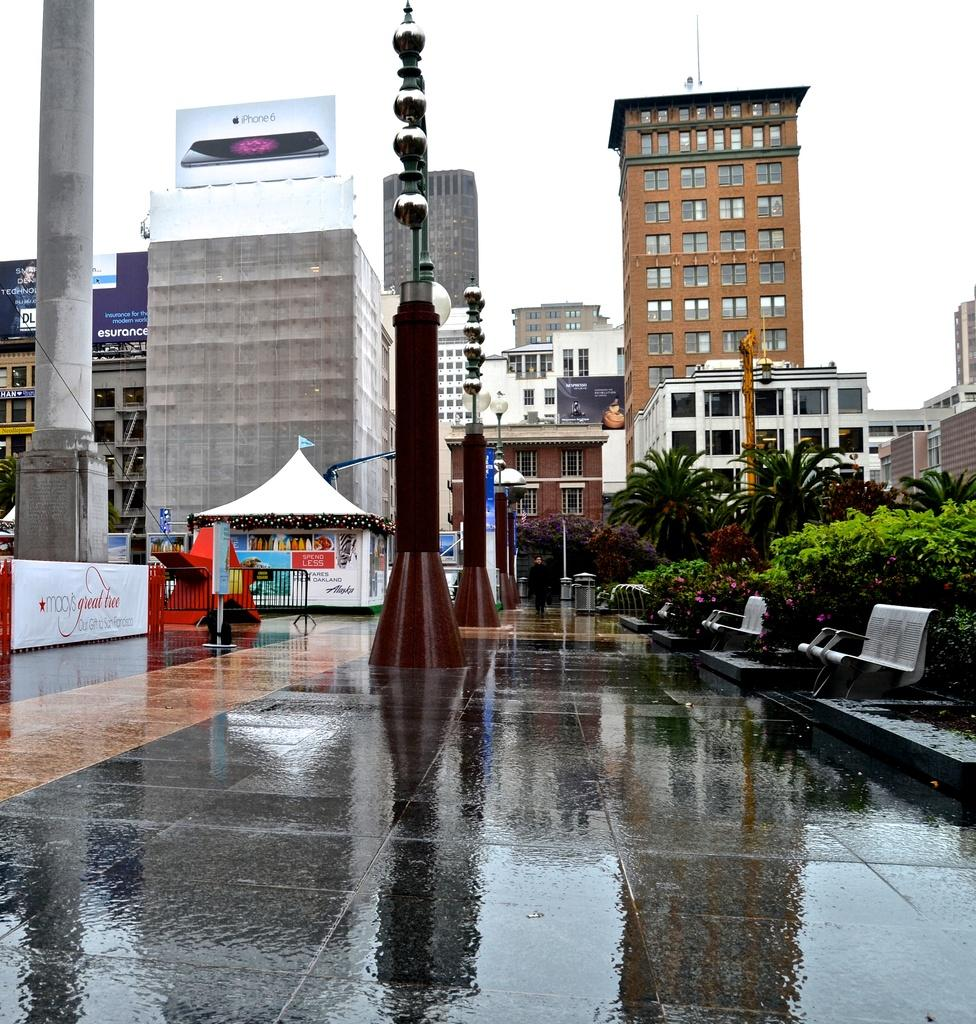What type of outdoor seating can be seen in the image? There are benches in the image. What type of vegetation is present in the image? There are trees in the image. What type of temporary shelter is visible in the image? There are tents in the image. What architectural features can be seen in the image? There are pillars and buildings in the image. What part of the buildings can be seen in the image? There are windows in the image. What is visible in the background of the image? The sky is visible in the background of the image. Can you describe the weather conditions in the image? The image may have been taken during a rainy day, as suggested by the presence of tents and the possible dampness of the benches. What is the income of the person standing next to the tent in the image? There is no person standing next to the tent in the image, and therefore no income can be determined. How many steps are visible in the image? There are no steps visible in the image. 